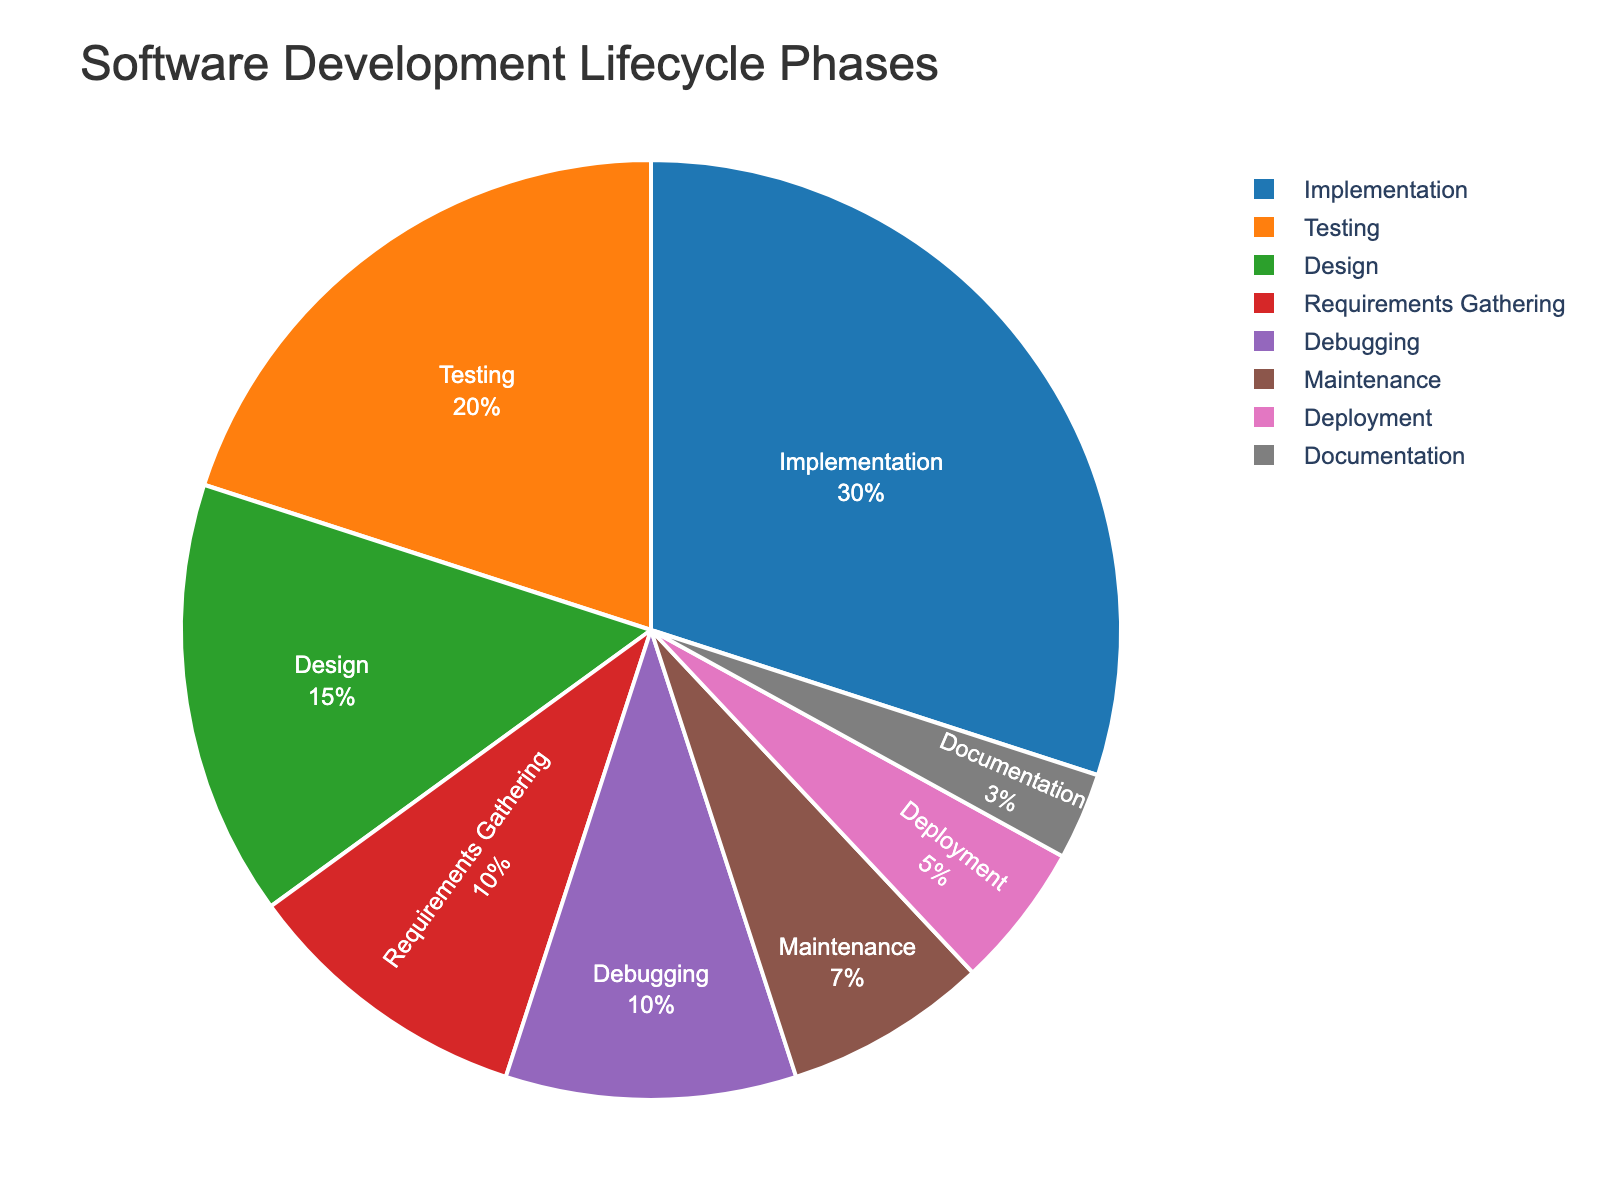What phase takes up the largest percentage of time? To determine the phase that takes up the largest percentage, we look for the segment with the largest proportion. The "Implementation" phase is the largest segment at 30%.
Answer: Implementation How much greater is the time spent on Implementation compared to Deployment? The time spent on Implementation is 30%, and for Deployment, it is 5%. The difference is calculated by subtracting Deployment from Implementation (30% - 5% = 25%).
Answer: 25% What is the combined percentage of time spent on Testing and Debugging? To find the combined percentage of Testing and Debugging, we add the percentages of both phases: Testing (20%) + Debugging (10%) = 30%.
Answer: 30% What is the smallest segment in the pie chart? The smallest segment is found by identifying the phase with the smallest percentage, which is "Documentation" at 3%.
Answer: Documentation Which phase is depicted in green in the pie chart? The phase depicted in green can be identified by matching the color to the segment, which is "Implementation".
Answer: Implementation Compare the total percentage of time spent on Design and Maintenance versus Requirements Gathering and Debugging. Which pair spends more time and by how much? Adding the percentages for Design and Maintenance (15% + 7% = 22%) and Requirements Gathering and Debugging (10% + 10% = 20%), we see Design and Maintenance spends 2% more time.
Answer: Design and Maintenance, 2% If the entire software development lifecycle represents 100 hours, how much time is allocated to Testing? To find the time allocated to Testing, convert the percentage into hours: 20% of 100 hours is 20 hours.
Answer: 20 hours Is more time spent on Deployment or Maintenance? By how much? Comparing the percentages, Deployment (5%) and Maintenance (7%), Maintenance is given more time by a difference of 7% - 5% = 2%.
Answer: Maintenance, 2% What's the average percentage of time spent on Design, Documentation, and Deployment? To find the average, add the percentages and divide by the number of phases: (15% + 3% + 5%) / 3 = 23% / 3 = 7.67%.
Answer: 7.67% What percentage of the time is spent on phases other than Implementation? First, we subtract the Implementation percentage from 100%: 100% - 30% = 70%. Therefore, 70% of the time is spent on phases other than Implementation.
Answer: 70% 